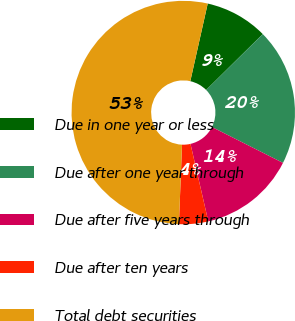Convert chart. <chart><loc_0><loc_0><loc_500><loc_500><pie_chart><fcel>Due in one year or less<fcel>Due after one year through<fcel>Due after five years through<fcel>Due after ten years<fcel>Total debt securities<nl><fcel>9.09%<fcel>19.84%<fcel>13.96%<fcel>4.22%<fcel>52.89%<nl></chart> 